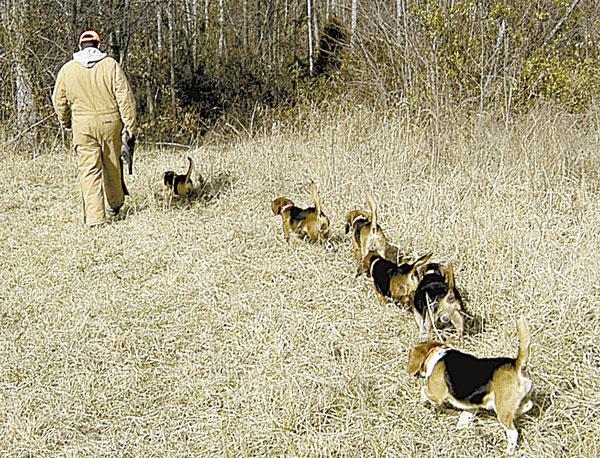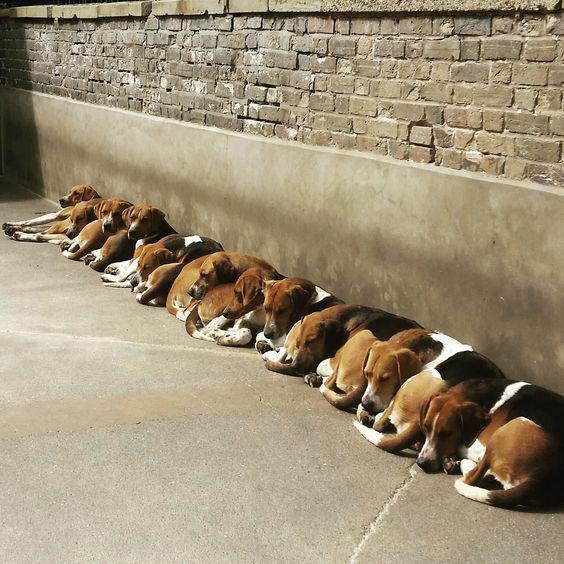The first image is the image on the left, the second image is the image on the right. Evaluate the accuracy of this statement regarding the images: "No image contains more than one beagle dog, and at least one dog looks directly at the camera.". Is it true? Answer yes or no. No. The first image is the image on the left, the second image is the image on the right. Considering the images on both sides, is "Each image shows exactly one beagle, and at least one beagle is looking at the camera." valid? Answer yes or no. No. 